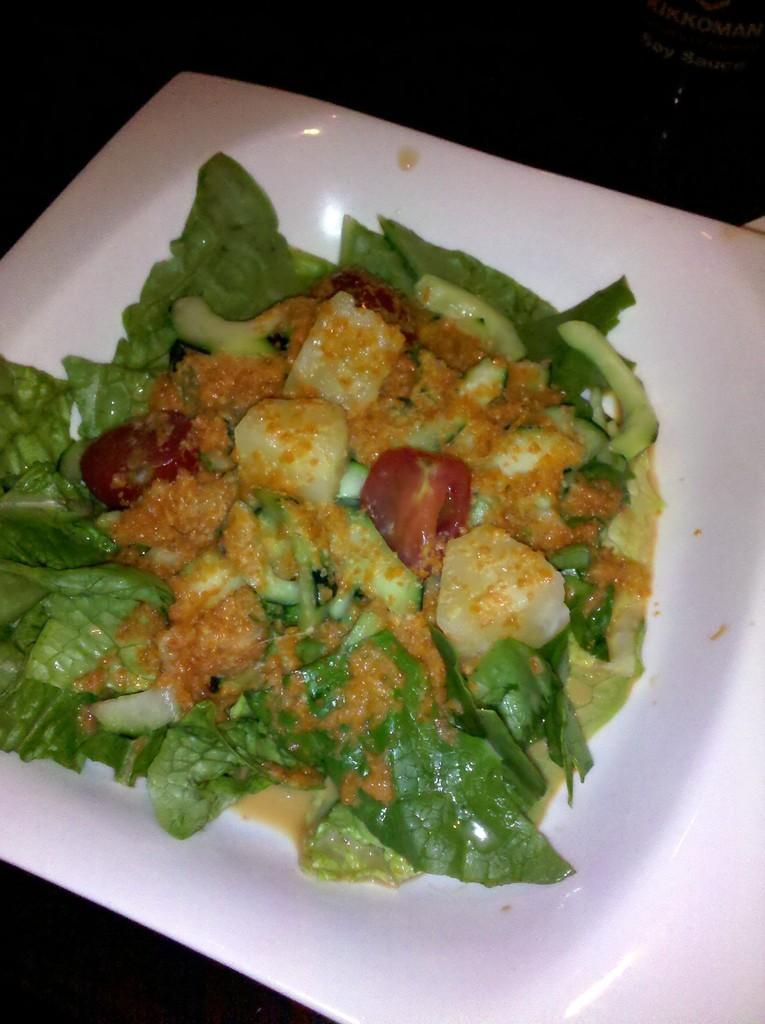Please provide a concise description of this image. In this picture we can see green vegetable food, place in the white plate. 